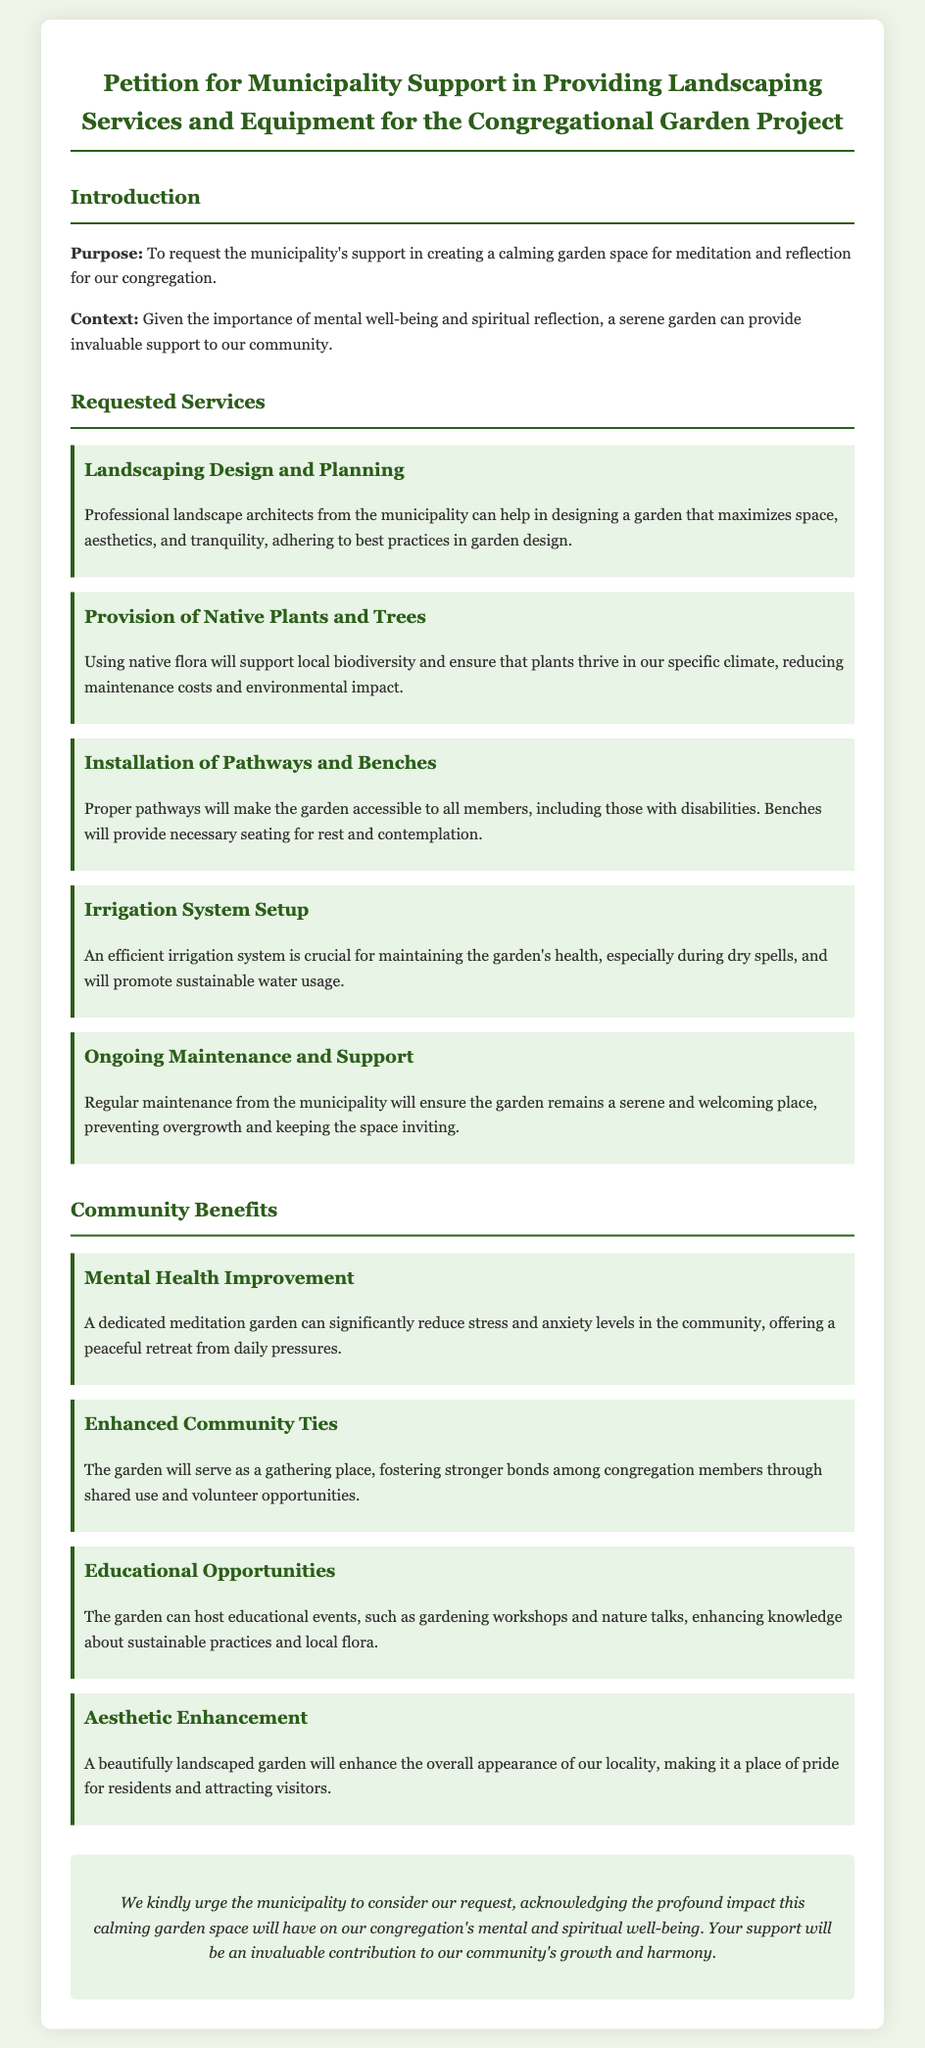What is the purpose of the petition? The purpose is to request the municipality's support in creating a calming garden space for meditation and reflection for the congregation.
Answer: To request municipality support for a calming garden space What is one of the requested services? The document lists multiple requested services, one of which is landscaping design and planning.
Answer: Landscaping Design and Planning What is the benefit of using native plants in the garden? The document states using native flora will support local biodiversity and ensure that plants thrive in the specific climate.
Answer: Support local biodiversity How many community benefits are listed in the document? The document lists four community benefits: mental health improvement, enhanced community ties, educational opportunities, and aesthetic enhancement.
Answer: Four Which service is focused on accessibility? The installation of pathways and benches is highlighted for making the garden accessible to all members, including those with disabilities.
Answer: Installation of Pathways and Benches What type of garden space is being proposed? The proposed garden space is a dedicated meditation garden for reflection and serenity.
Answer: Meditation garden What is the conclusion's call to action? The conclusion urges the municipality to consider the request for support in creating the garden space.
Answer: Consider our request What does the irrigation system setup promote? The irrigation system setup promotes sustainable water usage in maintaining the garden's health.
Answer: Sustainable water usage 